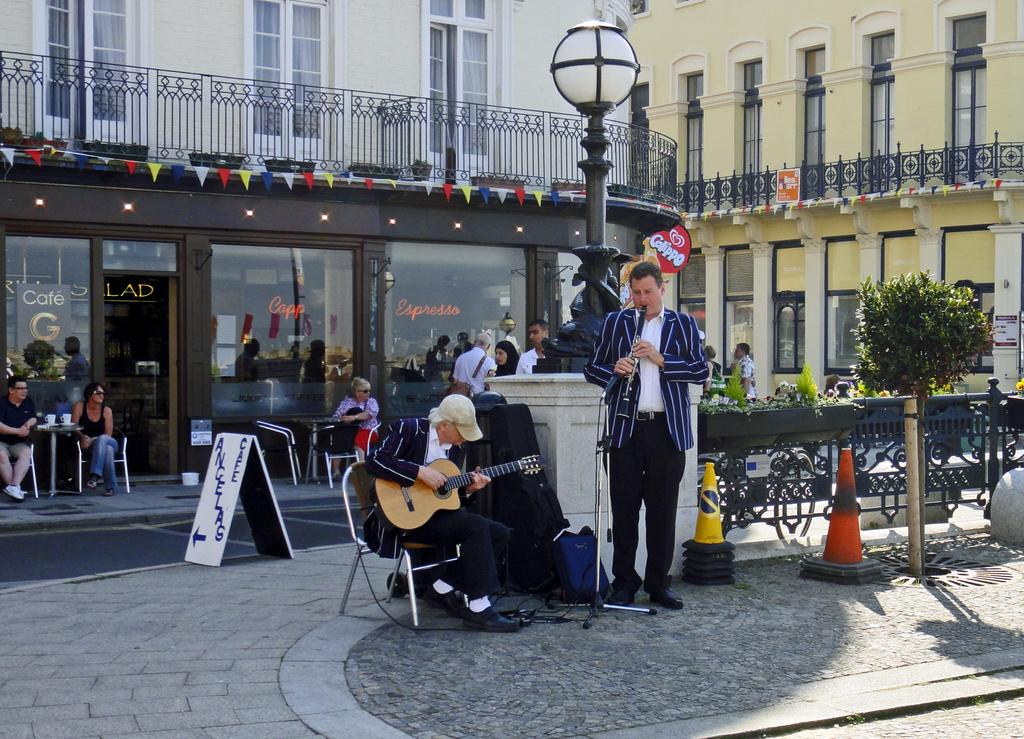What is the man in the image doing while sitting on a chair? The man is playing a guitar. Can you describe the other person in the image? There is a man standing in the image, and he is also playing a musical instrument. What can be seen in the background of the image? There is a building and a railing in the background of the image. What book is the man reading while sitting on a chair? There is no book present in the image; the man is playing a guitar. What type of crime is being committed in the image? There is no crime being committed in the image; it features two men playing musical instruments. 